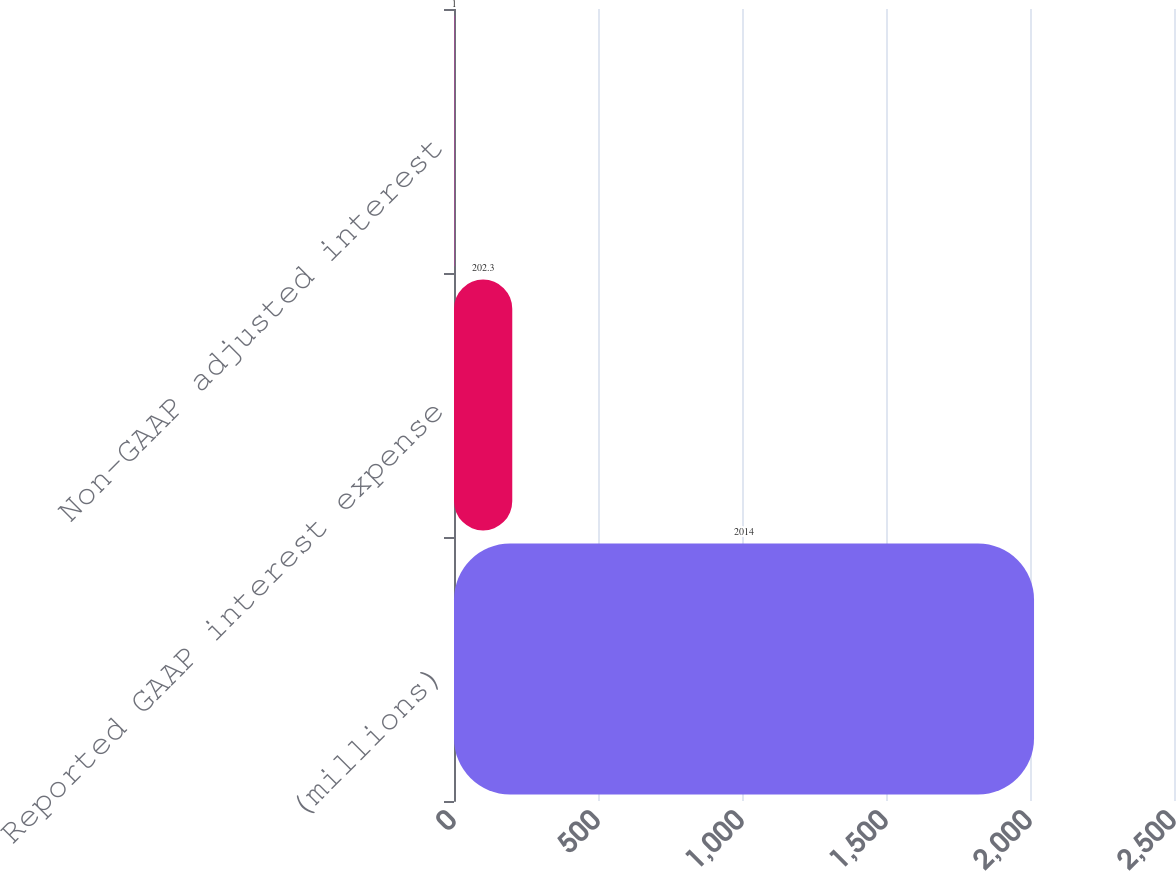Convert chart to OTSL. <chart><loc_0><loc_0><loc_500><loc_500><bar_chart><fcel>(millions)<fcel>Reported GAAP interest expense<fcel>Non-GAAP adjusted interest<nl><fcel>2014<fcel>202.3<fcel>1<nl></chart> 